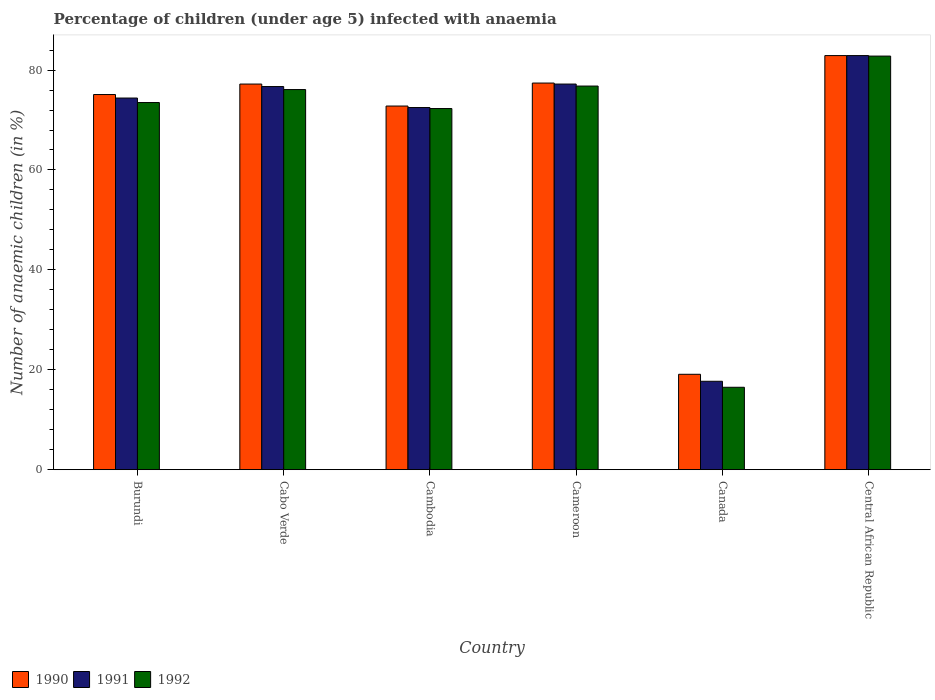How many different coloured bars are there?
Provide a succinct answer. 3. Are the number of bars per tick equal to the number of legend labels?
Ensure brevity in your answer.  Yes. Are the number of bars on each tick of the X-axis equal?
Keep it short and to the point. Yes. How many bars are there on the 1st tick from the left?
Ensure brevity in your answer.  3. What is the label of the 2nd group of bars from the left?
Give a very brief answer. Cabo Verde. In how many cases, is the number of bars for a given country not equal to the number of legend labels?
Provide a short and direct response. 0. What is the percentage of children infected with anaemia in in 1990 in Central African Republic?
Your response must be concise. 82.9. Across all countries, what is the maximum percentage of children infected with anaemia in in 1990?
Offer a very short reply. 82.9. In which country was the percentage of children infected with anaemia in in 1991 maximum?
Provide a succinct answer. Central African Republic. What is the total percentage of children infected with anaemia in in 1990 in the graph?
Your answer should be compact. 404.5. What is the difference between the percentage of children infected with anaemia in in 1990 in Cabo Verde and that in Cameroon?
Your response must be concise. -0.2. What is the difference between the percentage of children infected with anaemia in in 1992 in Cabo Verde and the percentage of children infected with anaemia in in 1991 in Cameroon?
Make the answer very short. -1.1. What is the average percentage of children infected with anaemia in in 1990 per country?
Your response must be concise. 67.42. What is the difference between the percentage of children infected with anaemia in of/in 1990 and percentage of children infected with anaemia in of/in 1992 in Cameroon?
Keep it short and to the point. 0.6. What is the ratio of the percentage of children infected with anaemia in in 1991 in Burundi to that in Cabo Verde?
Give a very brief answer. 0.97. Is the percentage of children infected with anaemia in in 1992 in Cameroon less than that in Canada?
Provide a short and direct response. No. What is the difference between the highest and the second highest percentage of children infected with anaemia in in 1992?
Ensure brevity in your answer.  6. What is the difference between the highest and the lowest percentage of children infected with anaemia in in 1991?
Your answer should be very brief. 65.2. Is the sum of the percentage of children infected with anaemia in in 1991 in Cameroon and Central African Republic greater than the maximum percentage of children infected with anaemia in in 1990 across all countries?
Give a very brief answer. Yes. What does the 1st bar from the left in Central African Republic represents?
Ensure brevity in your answer.  1990. How many bars are there?
Your answer should be compact. 18. How many countries are there in the graph?
Provide a short and direct response. 6. Does the graph contain grids?
Keep it short and to the point. No. How are the legend labels stacked?
Your response must be concise. Horizontal. What is the title of the graph?
Give a very brief answer. Percentage of children (under age 5) infected with anaemia. What is the label or title of the Y-axis?
Provide a succinct answer. Number of anaemic children (in %). What is the Number of anaemic children (in %) in 1990 in Burundi?
Make the answer very short. 75.1. What is the Number of anaemic children (in %) of 1991 in Burundi?
Your answer should be very brief. 74.4. What is the Number of anaemic children (in %) in 1992 in Burundi?
Provide a succinct answer. 73.5. What is the Number of anaemic children (in %) in 1990 in Cabo Verde?
Provide a short and direct response. 77.2. What is the Number of anaemic children (in %) of 1991 in Cabo Verde?
Ensure brevity in your answer.  76.7. What is the Number of anaemic children (in %) in 1992 in Cabo Verde?
Keep it short and to the point. 76.1. What is the Number of anaemic children (in %) of 1990 in Cambodia?
Your answer should be very brief. 72.8. What is the Number of anaemic children (in %) of 1991 in Cambodia?
Give a very brief answer. 72.5. What is the Number of anaemic children (in %) in 1992 in Cambodia?
Make the answer very short. 72.3. What is the Number of anaemic children (in %) of 1990 in Cameroon?
Your answer should be very brief. 77.4. What is the Number of anaemic children (in %) of 1991 in Cameroon?
Offer a terse response. 77.2. What is the Number of anaemic children (in %) in 1992 in Cameroon?
Give a very brief answer. 76.8. What is the Number of anaemic children (in %) of 1990 in Canada?
Provide a succinct answer. 19.1. What is the Number of anaemic children (in %) of 1991 in Canada?
Give a very brief answer. 17.7. What is the Number of anaemic children (in %) in 1990 in Central African Republic?
Your response must be concise. 82.9. What is the Number of anaemic children (in %) of 1991 in Central African Republic?
Keep it short and to the point. 82.9. What is the Number of anaemic children (in %) in 1992 in Central African Republic?
Your response must be concise. 82.8. Across all countries, what is the maximum Number of anaemic children (in %) of 1990?
Your response must be concise. 82.9. Across all countries, what is the maximum Number of anaemic children (in %) in 1991?
Offer a very short reply. 82.9. Across all countries, what is the maximum Number of anaemic children (in %) of 1992?
Offer a very short reply. 82.8. Across all countries, what is the minimum Number of anaemic children (in %) of 1991?
Keep it short and to the point. 17.7. What is the total Number of anaemic children (in %) in 1990 in the graph?
Your response must be concise. 404.5. What is the total Number of anaemic children (in %) in 1991 in the graph?
Keep it short and to the point. 401.4. What is the total Number of anaemic children (in %) in 1992 in the graph?
Give a very brief answer. 398. What is the difference between the Number of anaemic children (in %) in 1991 in Burundi and that in Cabo Verde?
Provide a short and direct response. -2.3. What is the difference between the Number of anaemic children (in %) of 1992 in Burundi and that in Cabo Verde?
Give a very brief answer. -2.6. What is the difference between the Number of anaemic children (in %) of 1991 in Burundi and that in Cambodia?
Your response must be concise. 1.9. What is the difference between the Number of anaemic children (in %) of 1992 in Burundi and that in Cambodia?
Your answer should be very brief. 1.2. What is the difference between the Number of anaemic children (in %) in 1992 in Burundi and that in Cameroon?
Keep it short and to the point. -3.3. What is the difference between the Number of anaemic children (in %) in 1991 in Burundi and that in Canada?
Give a very brief answer. 56.7. What is the difference between the Number of anaemic children (in %) of 1992 in Burundi and that in Canada?
Provide a short and direct response. 57. What is the difference between the Number of anaemic children (in %) of 1990 in Burundi and that in Central African Republic?
Provide a short and direct response. -7.8. What is the difference between the Number of anaemic children (in %) of 1990 in Cabo Verde and that in Cambodia?
Offer a terse response. 4.4. What is the difference between the Number of anaemic children (in %) in 1990 in Cabo Verde and that in Cameroon?
Keep it short and to the point. -0.2. What is the difference between the Number of anaemic children (in %) of 1991 in Cabo Verde and that in Cameroon?
Your answer should be very brief. -0.5. What is the difference between the Number of anaemic children (in %) of 1990 in Cabo Verde and that in Canada?
Offer a very short reply. 58.1. What is the difference between the Number of anaemic children (in %) in 1992 in Cabo Verde and that in Canada?
Your answer should be compact. 59.6. What is the difference between the Number of anaemic children (in %) in 1990 in Cambodia and that in Cameroon?
Your response must be concise. -4.6. What is the difference between the Number of anaemic children (in %) of 1991 in Cambodia and that in Cameroon?
Provide a short and direct response. -4.7. What is the difference between the Number of anaemic children (in %) of 1990 in Cambodia and that in Canada?
Offer a terse response. 53.7. What is the difference between the Number of anaemic children (in %) in 1991 in Cambodia and that in Canada?
Make the answer very short. 54.8. What is the difference between the Number of anaemic children (in %) in 1992 in Cambodia and that in Canada?
Offer a very short reply. 55.8. What is the difference between the Number of anaemic children (in %) of 1992 in Cambodia and that in Central African Republic?
Ensure brevity in your answer.  -10.5. What is the difference between the Number of anaemic children (in %) in 1990 in Cameroon and that in Canada?
Your response must be concise. 58.3. What is the difference between the Number of anaemic children (in %) in 1991 in Cameroon and that in Canada?
Provide a succinct answer. 59.5. What is the difference between the Number of anaemic children (in %) of 1992 in Cameroon and that in Canada?
Your answer should be very brief. 60.3. What is the difference between the Number of anaemic children (in %) of 1990 in Cameroon and that in Central African Republic?
Your answer should be compact. -5.5. What is the difference between the Number of anaemic children (in %) in 1992 in Cameroon and that in Central African Republic?
Your answer should be compact. -6. What is the difference between the Number of anaemic children (in %) in 1990 in Canada and that in Central African Republic?
Offer a terse response. -63.8. What is the difference between the Number of anaemic children (in %) of 1991 in Canada and that in Central African Republic?
Offer a very short reply. -65.2. What is the difference between the Number of anaemic children (in %) of 1992 in Canada and that in Central African Republic?
Your answer should be compact. -66.3. What is the difference between the Number of anaemic children (in %) in 1990 in Burundi and the Number of anaemic children (in %) in 1992 in Cabo Verde?
Your answer should be very brief. -1. What is the difference between the Number of anaemic children (in %) in 1991 in Burundi and the Number of anaemic children (in %) in 1992 in Cabo Verde?
Provide a succinct answer. -1.7. What is the difference between the Number of anaemic children (in %) in 1991 in Burundi and the Number of anaemic children (in %) in 1992 in Cambodia?
Provide a short and direct response. 2.1. What is the difference between the Number of anaemic children (in %) of 1990 in Burundi and the Number of anaemic children (in %) of 1991 in Cameroon?
Your answer should be very brief. -2.1. What is the difference between the Number of anaemic children (in %) of 1990 in Burundi and the Number of anaemic children (in %) of 1992 in Cameroon?
Provide a succinct answer. -1.7. What is the difference between the Number of anaemic children (in %) in 1990 in Burundi and the Number of anaemic children (in %) in 1991 in Canada?
Offer a very short reply. 57.4. What is the difference between the Number of anaemic children (in %) of 1990 in Burundi and the Number of anaemic children (in %) of 1992 in Canada?
Your answer should be compact. 58.6. What is the difference between the Number of anaemic children (in %) of 1991 in Burundi and the Number of anaemic children (in %) of 1992 in Canada?
Provide a short and direct response. 57.9. What is the difference between the Number of anaemic children (in %) in 1990 in Burundi and the Number of anaemic children (in %) in 1991 in Central African Republic?
Your answer should be compact. -7.8. What is the difference between the Number of anaemic children (in %) in 1990 in Burundi and the Number of anaemic children (in %) in 1992 in Central African Republic?
Your answer should be compact. -7.7. What is the difference between the Number of anaemic children (in %) in 1990 in Cabo Verde and the Number of anaemic children (in %) in 1992 in Cambodia?
Give a very brief answer. 4.9. What is the difference between the Number of anaemic children (in %) of 1990 in Cabo Verde and the Number of anaemic children (in %) of 1992 in Cameroon?
Provide a succinct answer. 0.4. What is the difference between the Number of anaemic children (in %) of 1990 in Cabo Verde and the Number of anaemic children (in %) of 1991 in Canada?
Provide a succinct answer. 59.5. What is the difference between the Number of anaemic children (in %) of 1990 in Cabo Verde and the Number of anaemic children (in %) of 1992 in Canada?
Your answer should be very brief. 60.7. What is the difference between the Number of anaemic children (in %) in 1991 in Cabo Verde and the Number of anaemic children (in %) in 1992 in Canada?
Give a very brief answer. 60.2. What is the difference between the Number of anaemic children (in %) in 1990 in Cabo Verde and the Number of anaemic children (in %) in 1992 in Central African Republic?
Your answer should be compact. -5.6. What is the difference between the Number of anaemic children (in %) of 1991 in Cabo Verde and the Number of anaemic children (in %) of 1992 in Central African Republic?
Offer a very short reply. -6.1. What is the difference between the Number of anaemic children (in %) of 1990 in Cambodia and the Number of anaemic children (in %) of 1991 in Canada?
Provide a succinct answer. 55.1. What is the difference between the Number of anaemic children (in %) in 1990 in Cambodia and the Number of anaemic children (in %) in 1992 in Canada?
Provide a short and direct response. 56.3. What is the difference between the Number of anaemic children (in %) in 1991 in Cambodia and the Number of anaemic children (in %) in 1992 in Canada?
Provide a short and direct response. 56. What is the difference between the Number of anaemic children (in %) in 1990 in Cambodia and the Number of anaemic children (in %) in 1991 in Central African Republic?
Make the answer very short. -10.1. What is the difference between the Number of anaemic children (in %) of 1991 in Cambodia and the Number of anaemic children (in %) of 1992 in Central African Republic?
Keep it short and to the point. -10.3. What is the difference between the Number of anaemic children (in %) of 1990 in Cameroon and the Number of anaemic children (in %) of 1991 in Canada?
Your answer should be very brief. 59.7. What is the difference between the Number of anaemic children (in %) of 1990 in Cameroon and the Number of anaemic children (in %) of 1992 in Canada?
Provide a short and direct response. 60.9. What is the difference between the Number of anaemic children (in %) in 1991 in Cameroon and the Number of anaemic children (in %) in 1992 in Canada?
Provide a succinct answer. 60.7. What is the difference between the Number of anaemic children (in %) in 1990 in Cameroon and the Number of anaemic children (in %) in 1992 in Central African Republic?
Keep it short and to the point. -5.4. What is the difference between the Number of anaemic children (in %) of 1990 in Canada and the Number of anaemic children (in %) of 1991 in Central African Republic?
Provide a succinct answer. -63.8. What is the difference between the Number of anaemic children (in %) of 1990 in Canada and the Number of anaemic children (in %) of 1992 in Central African Republic?
Your answer should be compact. -63.7. What is the difference between the Number of anaemic children (in %) of 1991 in Canada and the Number of anaemic children (in %) of 1992 in Central African Republic?
Provide a succinct answer. -65.1. What is the average Number of anaemic children (in %) of 1990 per country?
Your answer should be compact. 67.42. What is the average Number of anaemic children (in %) in 1991 per country?
Offer a very short reply. 66.9. What is the average Number of anaemic children (in %) in 1992 per country?
Offer a terse response. 66.33. What is the difference between the Number of anaemic children (in %) in 1990 and Number of anaemic children (in %) in 1991 in Burundi?
Keep it short and to the point. 0.7. What is the difference between the Number of anaemic children (in %) of 1990 and Number of anaemic children (in %) of 1992 in Burundi?
Your answer should be very brief. 1.6. What is the difference between the Number of anaemic children (in %) in 1991 and Number of anaemic children (in %) in 1992 in Burundi?
Your answer should be very brief. 0.9. What is the difference between the Number of anaemic children (in %) in 1990 and Number of anaemic children (in %) in 1991 in Cambodia?
Offer a terse response. 0.3. What is the difference between the Number of anaemic children (in %) of 1990 and Number of anaemic children (in %) of 1992 in Cambodia?
Keep it short and to the point. 0.5. What is the difference between the Number of anaemic children (in %) in 1991 and Number of anaemic children (in %) in 1992 in Cameroon?
Keep it short and to the point. 0.4. What is the difference between the Number of anaemic children (in %) in 1990 and Number of anaemic children (in %) in 1992 in Canada?
Provide a short and direct response. 2.6. What is the difference between the Number of anaemic children (in %) of 1991 and Number of anaemic children (in %) of 1992 in Canada?
Offer a terse response. 1.2. What is the difference between the Number of anaemic children (in %) in 1991 and Number of anaemic children (in %) in 1992 in Central African Republic?
Ensure brevity in your answer.  0.1. What is the ratio of the Number of anaemic children (in %) of 1990 in Burundi to that in Cabo Verde?
Keep it short and to the point. 0.97. What is the ratio of the Number of anaemic children (in %) of 1992 in Burundi to that in Cabo Verde?
Provide a short and direct response. 0.97. What is the ratio of the Number of anaemic children (in %) of 1990 in Burundi to that in Cambodia?
Provide a short and direct response. 1.03. What is the ratio of the Number of anaemic children (in %) of 1991 in Burundi to that in Cambodia?
Offer a terse response. 1.03. What is the ratio of the Number of anaemic children (in %) in 1992 in Burundi to that in Cambodia?
Provide a short and direct response. 1.02. What is the ratio of the Number of anaemic children (in %) of 1990 in Burundi to that in Cameroon?
Your response must be concise. 0.97. What is the ratio of the Number of anaemic children (in %) in 1991 in Burundi to that in Cameroon?
Your answer should be compact. 0.96. What is the ratio of the Number of anaemic children (in %) of 1990 in Burundi to that in Canada?
Provide a succinct answer. 3.93. What is the ratio of the Number of anaemic children (in %) of 1991 in Burundi to that in Canada?
Ensure brevity in your answer.  4.2. What is the ratio of the Number of anaemic children (in %) in 1992 in Burundi to that in Canada?
Your response must be concise. 4.45. What is the ratio of the Number of anaemic children (in %) of 1990 in Burundi to that in Central African Republic?
Give a very brief answer. 0.91. What is the ratio of the Number of anaemic children (in %) of 1991 in Burundi to that in Central African Republic?
Your answer should be very brief. 0.9. What is the ratio of the Number of anaemic children (in %) in 1992 in Burundi to that in Central African Republic?
Keep it short and to the point. 0.89. What is the ratio of the Number of anaemic children (in %) of 1990 in Cabo Verde to that in Cambodia?
Make the answer very short. 1.06. What is the ratio of the Number of anaemic children (in %) of 1991 in Cabo Verde to that in Cambodia?
Provide a short and direct response. 1.06. What is the ratio of the Number of anaemic children (in %) in 1992 in Cabo Verde to that in Cambodia?
Offer a terse response. 1.05. What is the ratio of the Number of anaemic children (in %) in 1990 in Cabo Verde to that in Cameroon?
Your answer should be compact. 1. What is the ratio of the Number of anaemic children (in %) of 1992 in Cabo Verde to that in Cameroon?
Your response must be concise. 0.99. What is the ratio of the Number of anaemic children (in %) in 1990 in Cabo Verde to that in Canada?
Make the answer very short. 4.04. What is the ratio of the Number of anaemic children (in %) of 1991 in Cabo Verde to that in Canada?
Offer a terse response. 4.33. What is the ratio of the Number of anaemic children (in %) in 1992 in Cabo Verde to that in Canada?
Your answer should be very brief. 4.61. What is the ratio of the Number of anaemic children (in %) in 1990 in Cabo Verde to that in Central African Republic?
Keep it short and to the point. 0.93. What is the ratio of the Number of anaemic children (in %) of 1991 in Cabo Verde to that in Central African Republic?
Keep it short and to the point. 0.93. What is the ratio of the Number of anaemic children (in %) of 1992 in Cabo Verde to that in Central African Republic?
Offer a very short reply. 0.92. What is the ratio of the Number of anaemic children (in %) of 1990 in Cambodia to that in Cameroon?
Provide a short and direct response. 0.94. What is the ratio of the Number of anaemic children (in %) in 1991 in Cambodia to that in Cameroon?
Offer a very short reply. 0.94. What is the ratio of the Number of anaemic children (in %) of 1992 in Cambodia to that in Cameroon?
Keep it short and to the point. 0.94. What is the ratio of the Number of anaemic children (in %) of 1990 in Cambodia to that in Canada?
Provide a succinct answer. 3.81. What is the ratio of the Number of anaemic children (in %) of 1991 in Cambodia to that in Canada?
Provide a succinct answer. 4.1. What is the ratio of the Number of anaemic children (in %) of 1992 in Cambodia to that in Canada?
Your response must be concise. 4.38. What is the ratio of the Number of anaemic children (in %) in 1990 in Cambodia to that in Central African Republic?
Your answer should be compact. 0.88. What is the ratio of the Number of anaemic children (in %) in 1991 in Cambodia to that in Central African Republic?
Your answer should be very brief. 0.87. What is the ratio of the Number of anaemic children (in %) of 1992 in Cambodia to that in Central African Republic?
Ensure brevity in your answer.  0.87. What is the ratio of the Number of anaemic children (in %) in 1990 in Cameroon to that in Canada?
Ensure brevity in your answer.  4.05. What is the ratio of the Number of anaemic children (in %) of 1991 in Cameroon to that in Canada?
Give a very brief answer. 4.36. What is the ratio of the Number of anaemic children (in %) of 1992 in Cameroon to that in Canada?
Give a very brief answer. 4.65. What is the ratio of the Number of anaemic children (in %) of 1990 in Cameroon to that in Central African Republic?
Your answer should be very brief. 0.93. What is the ratio of the Number of anaemic children (in %) of 1991 in Cameroon to that in Central African Republic?
Your answer should be compact. 0.93. What is the ratio of the Number of anaemic children (in %) in 1992 in Cameroon to that in Central African Republic?
Your answer should be compact. 0.93. What is the ratio of the Number of anaemic children (in %) of 1990 in Canada to that in Central African Republic?
Your response must be concise. 0.23. What is the ratio of the Number of anaemic children (in %) in 1991 in Canada to that in Central African Republic?
Your answer should be very brief. 0.21. What is the ratio of the Number of anaemic children (in %) of 1992 in Canada to that in Central African Republic?
Provide a succinct answer. 0.2. What is the difference between the highest and the second highest Number of anaemic children (in %) in 1990?
Ensure brevity in your answer.  5.5. What is the difference between the highest and the second highest Number of anaemic children (in %) of 1992?
Provide a succinct answer. 6. What is the difference between the highest and the lowest Number of anaemic children (in %) of 1990?
Offer a very short reply. 63.8. What is the difference between the highest and the lowest Number of anaemic children (in %) of 1991?
Provide a succinct answer. 65.2. What is the difference between the highest and the lowest Number of anaemic children (in %) of 1992?
Make the answer very short. 66.3. 